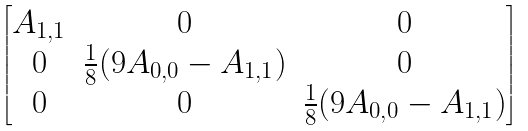<formula> <loc_0><loc_0><loc_500><loc_500>\begin{bmatrix} A _ { 1 , 1 } & 0 & 0 \\ 0 & \frac { 1 } { 8 } ( 9 A _ { 0 , 0 } - A _ { 1 , 1 } ) & 0 \\ 0 & 0 & \frac { 1 } { 8 } ( 9 A _ { 0 , 0 } - A _ { 1 , 1 } ) \end{bmatrix}</formula> 